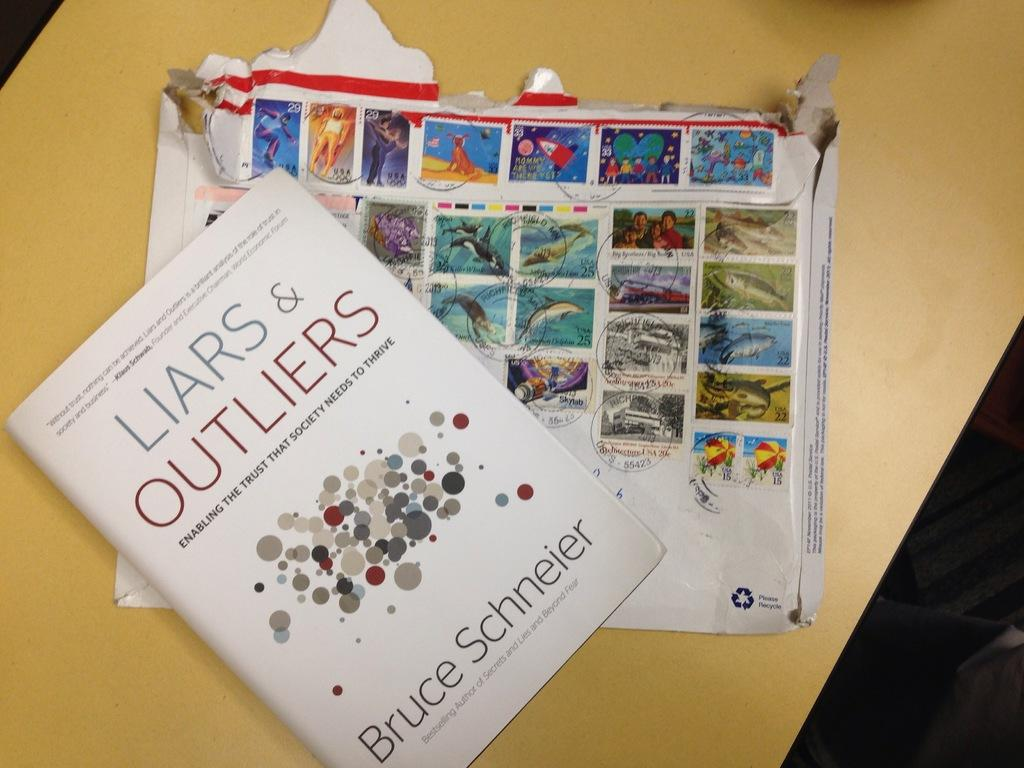<image>
Describe the image concisely. A book by Bruce Schneier is on a table. 